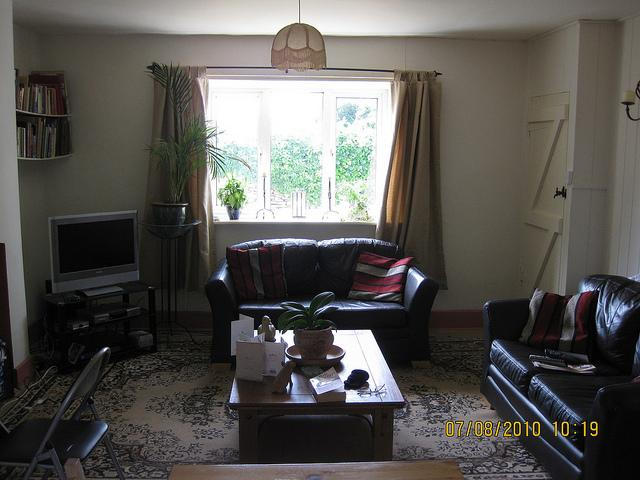What type of plant is on the coffee table? Please explain your reasoning. orchid. Orchids are big, green, and flat. 